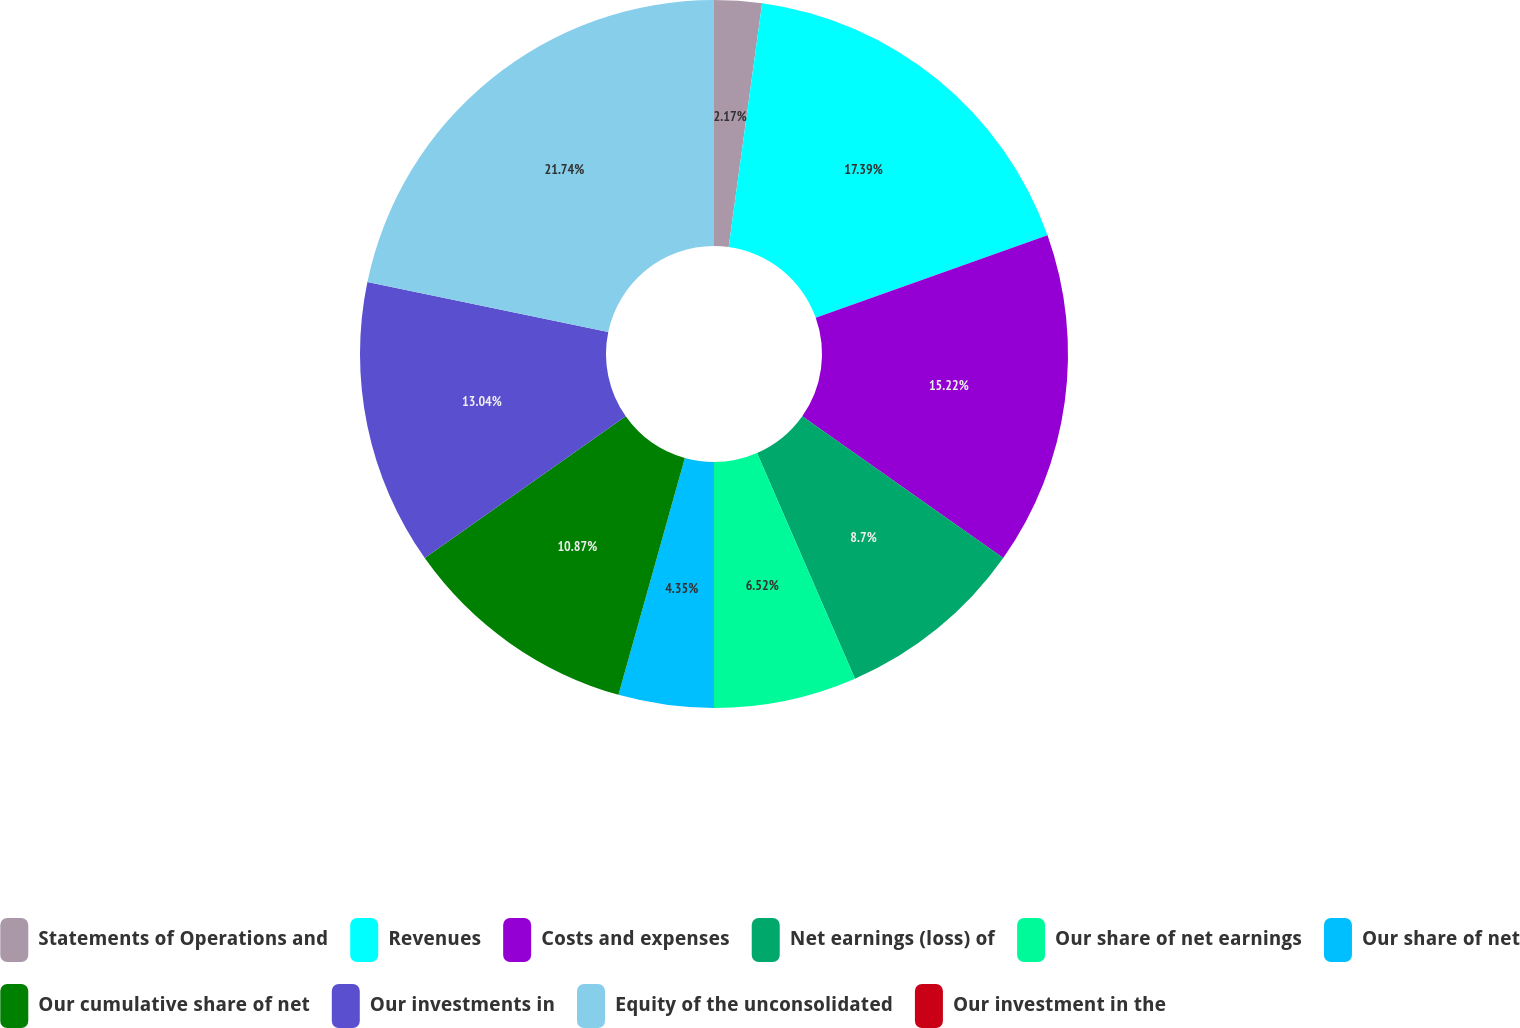Convert chart to OTSL. <chart><loc_0><loc_0><loc_500><loc_500><pie_chart><fcel>Statements of Operations and<fcel>Revenues<fcel>Costs and expenses<fcel>Net earnings (loss) of<fcel>Our share of net earnings<fcel>Our share of net<fcel>Our cumulative share of net<fcel>Our investments in<fcel>Equity of the unconsolidated<fcel>Our investment in the<nl><fcel>2.17%<fcel>17.39%<fcel>15.22%<fcel>8.7%<fcel>6.52%<fcel>4.35%<fcel>10.87%<fcel>13.04%<fcel>21.74%<fcel>0.0%<nl></chart> 